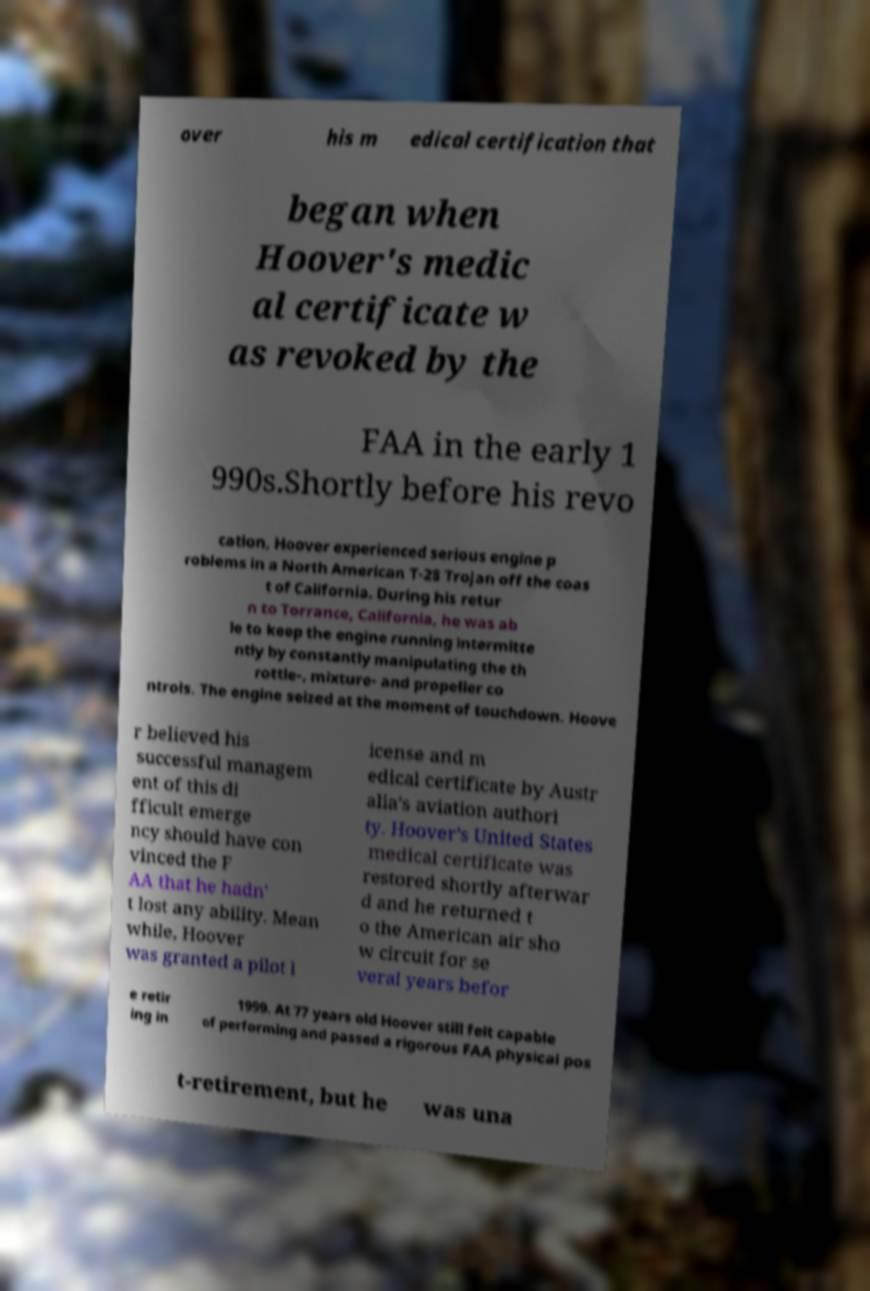There's text embedded in this image that I need extracted. Can you transcribe it verbatim? over his m edical certification that began when Hoover's medic al certificate w as revoked by the FAA in the early 1 990s.Shortly before his revo cation, Hoover experienced serious engine p roblems in a North American T-28 Trojan off the coas t of California. During his retur n to Torrance, California, he was ab le to keep the engine running intermitte ntly by constantly manipulating the th rottle-, mixture- and propeller co ntrols. The engine seized at the moment of touchdown. Hoove r believed his successful managem ent of this di fficult emerge ncy should have con vinced the F AA that he hadn' t lost any ability. Mean while, Hoover was granted a pilot l icense and m edical certificate by Austr alia's aviation authori ty. Hoover's United States medical certificate was restored shortly afterwar d and he returned t o the American air sho w circuit for se veral years befor e retir ing in 1999. At 77 years old Hoover still felt capable of performing and passed a rigorous FAA physical pos t-retirement, but he was una 